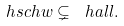Convert formula to latex. <formula><loc_0><loc_0><loc_500><loc_500>\ h s c h w \subsetneq \ h a l l .</formula> 